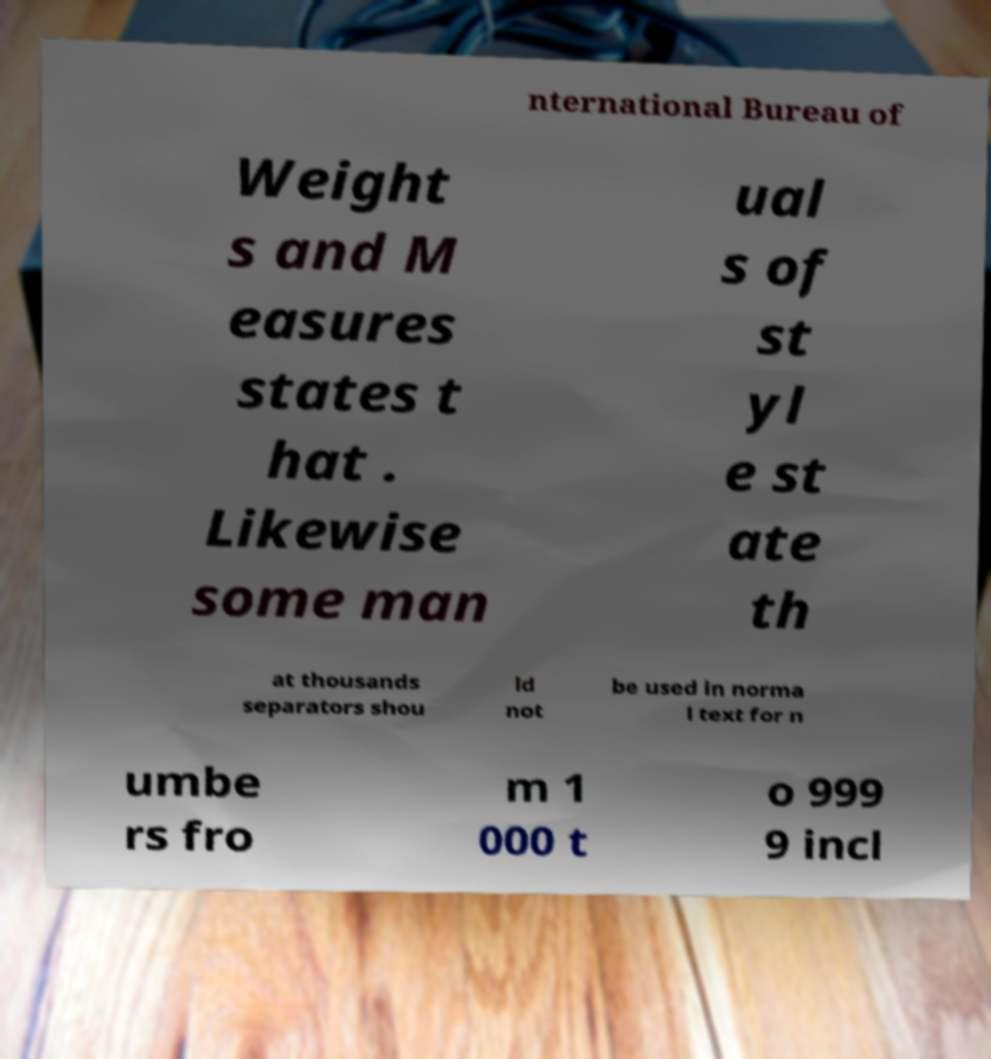Can you read and provide the text displayed in the image?This photo seems to have some interesting text. Can you extract and type it out for me? nternational Bureau of Weight s and M easures states t hat . Likewise some man ual s of st yl e st ate th at thousands separators shou ld not be used in norma l text for n umbe rs fro m 1 000 t o 999 9 incl 